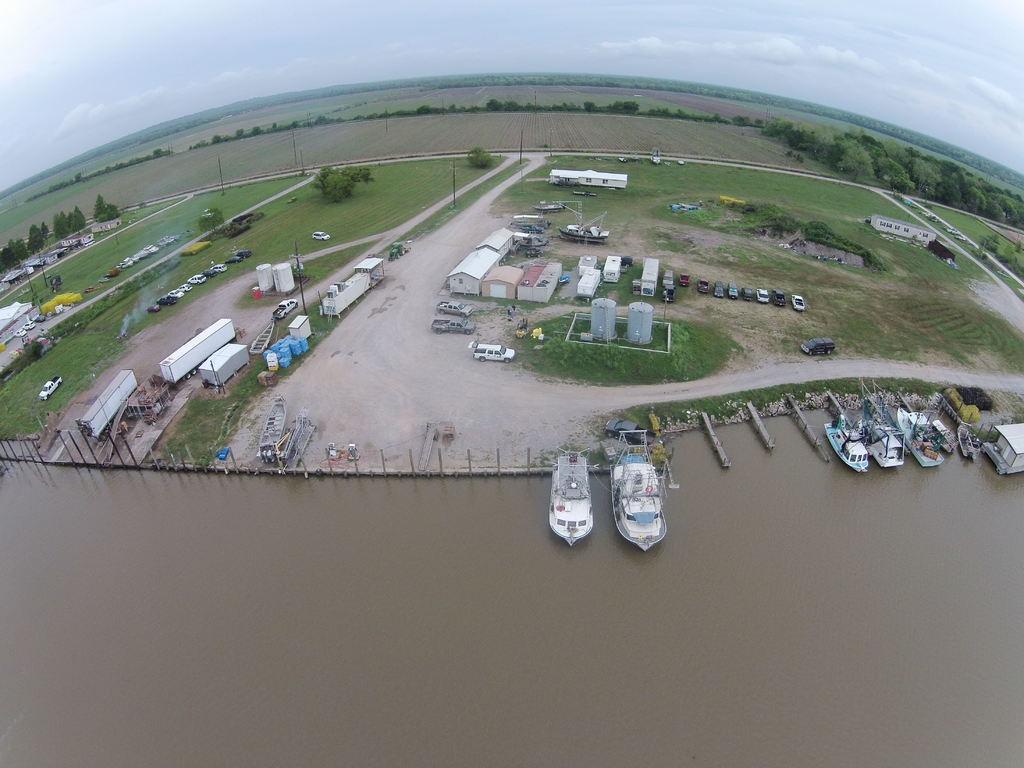Describe this image in one or two sentences. In the image I can see the top view of a place where we have some buildings, houses and also I can see some plants and some boats on the water. 